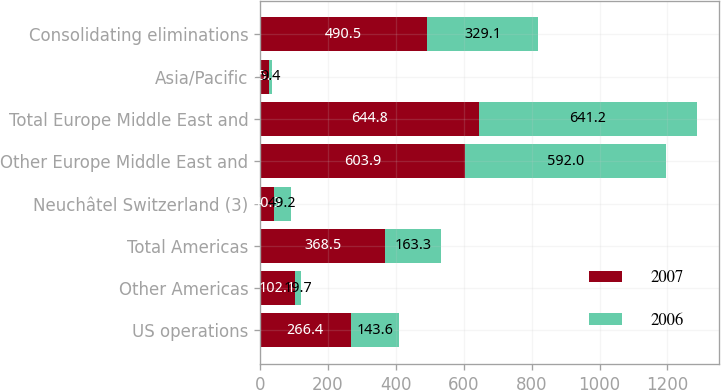Convert chart to OTSL. <chart><loc_0><loc_0><loc_500><loc_500><stacked_bar_chart><ecel><fcel>US operations<fcel>Other Americas<fcel>Total Americas<fcel>Neuchâtel Switzerland (3)<fcel>Other Europe Middle East and<fcel>Total Europe Middle East and<fcel>Asia/Pacific<fcel>Consolidating eliminations<nl><fcel>2007<fcel>266.4<fcel>102.1<fcel>368.5<fcel>40.9<fcel>603.9<fcel>644.8<fcel>25.2<fcel>490.5<nl><fcel>2006<fcel>143.6<fcel>19.7<fcel>163.3<fcel>49.2<fcel>592<fcel>641.2<fcel>9.4<fcel>329.1<nl></chart> 